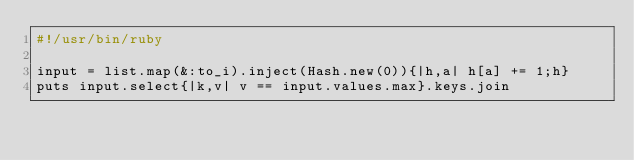Convert code to text. <code><loc_0><loc_0><loc_500><loc_500><_Ruby_>#!/usr/bin/ruby

input = list.map(&:to_i).inject(Hash.new(0)){|h,a| h[a] += 1;h}
puts input.select{|k,v| v == input.values.max}.keys.join</code> 